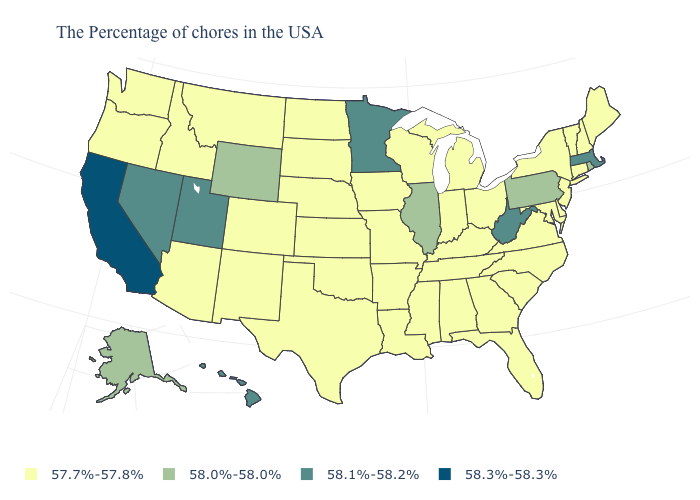What is the lowest value in the USA?
Be succinct. 57.7%-57.8%. Does Massachusetts have the same value as Hawaii?
Write a very short answer. Yes. Name the states that have a value in the range 57.7%-57.8%?
Keep it brief. Maine, New Hampshire, Vermont, Connecticut, New York, New Jersey, Delaware, Maryland, Virginia, North Carolina, South Carolina, Ohio, Florida, Georgia, Michigan, Kentucky, Indiana, Alabama, Tennessee, Wisconsin, Mississippi, Louisiana, Missouri, Arkansas, Iowa, Kansas, Nebraska, Oklahoma, Texas, South Dakota, North Dakota, Colorado, New Mexico, Montana, Arizona, Idaho, Washington, Oregon. What is the value of Wisconsin?
Keep it brief. 57.7%-57.8%. What is the value of Mississippi?
Quick response, please. 57.7%-57.8%. Does the map have missing data?
Give a very brief answer. No. Which states have the lowest value in the West?
Give a very brief answer. Colorado, New Mexico, Montana, Arizona, Idaho, Washington, Oregon. Name the states that have a value in the range 58.1%-58.2%?
Answer briefly. Massachusetts, West Virginia, Minnesota, Utah, Nevada, Hawaii. Name the states that have a value in the range 58.0%-58.0%?
Be succinct. Rhode Island, Pennsylvania, Illinois, Wyoming, Alaska. What is the value of West Virginia?
Write a very short answer. 58.1%-58.2%. Is the legend a continuous bar?
Write a very short answer. No. Does Ohio have the same value as West Virginia?
Give a very brief answer. No. What is the value of Oklahoma?
Concise answer only. 57.7%-57.8%. Does Virginia have the highest value in the USA?
Write a very short answer. No. Which states have the lowest value in the USA?
Concise answer only. Maine, New Hampshire, Vermont, Connecticut, New York, New Jersey, Delaware, Maryland, Virginia, North Carolina, South Carolina, Ohio, Florida, Georgia, Michigan, Kentucky, Indiana, Alabama, Tennessee, Wisconsin, Mississippi, Louisiana, Missouri, Arkansas, Iowa, Kansas, Nebraska, Oklahoma, Texas, South Dakota, North Dakota, Colorado, New Mexico, Montana, Arizona, Idaho, Washington, Oregon. 